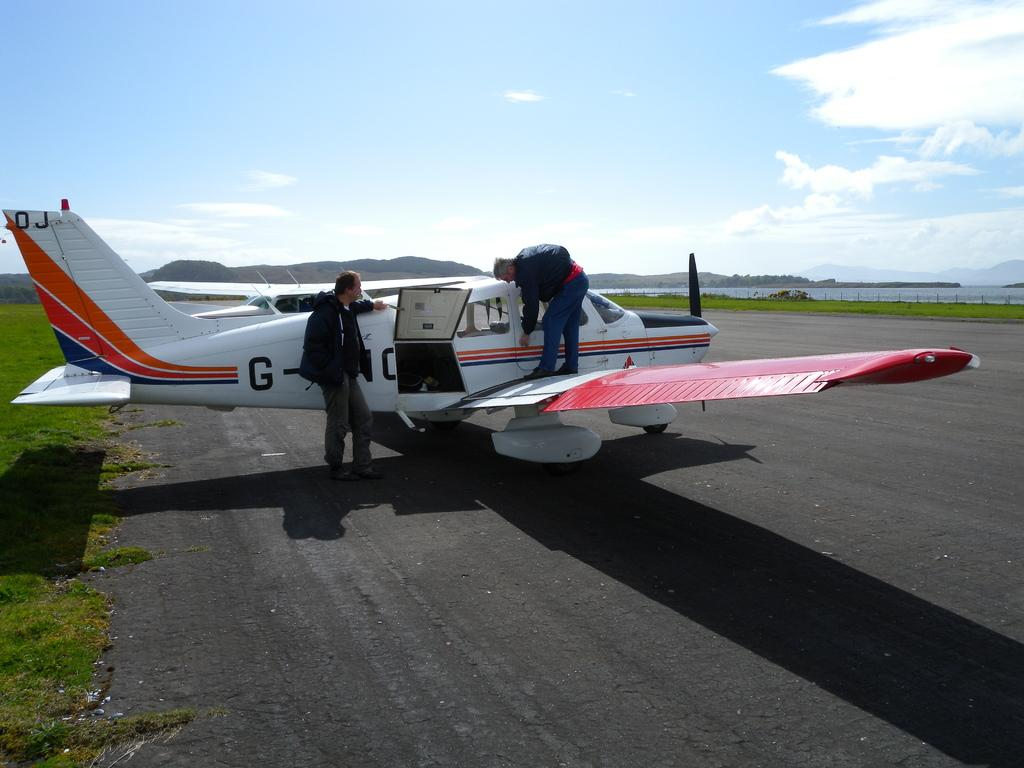What can be seen on the runway in the image? There are two airplanes on the runway in the image}. How many people are present in the image? There are two persons in the image}. What type of natural features can be seen in the image? There are trees and hills visible in the image. What is visible in the background of the image? The sky is visible in the background of the image. What type of cracker is the person holding in the image? There is no cracker present in the image. Who is the owner of the airplanes in the image? The image does not provide information about the ownership of the airplanes. 